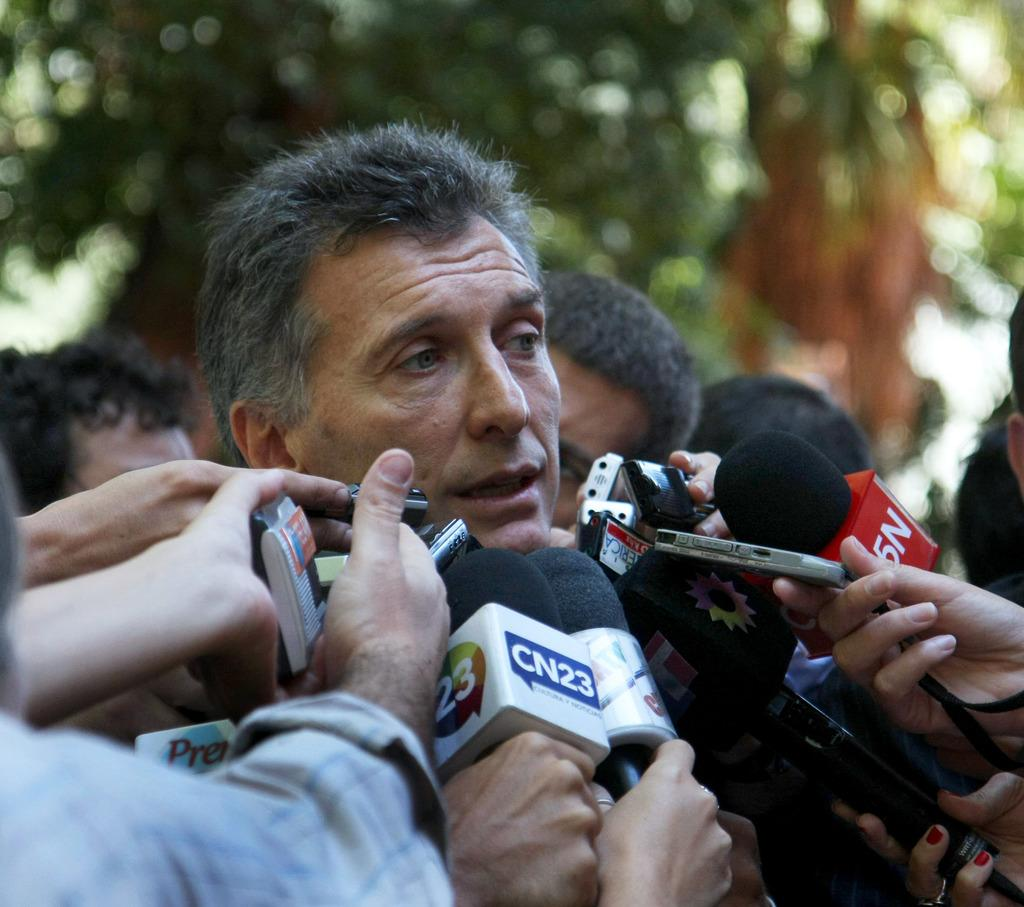What is happening in the image involving the group of people? There is a group of people standing in the image, and some of them are holding microphones. What can be seen in the background of the image? There are trees and the sky visible in the background of the image. What is the color of the trees in the image? The trees are green in color. What is the color of the sky in the image? The sky is white in color. What type of rice is being served to the toad in the image? There is no toad or rice present in the image. 